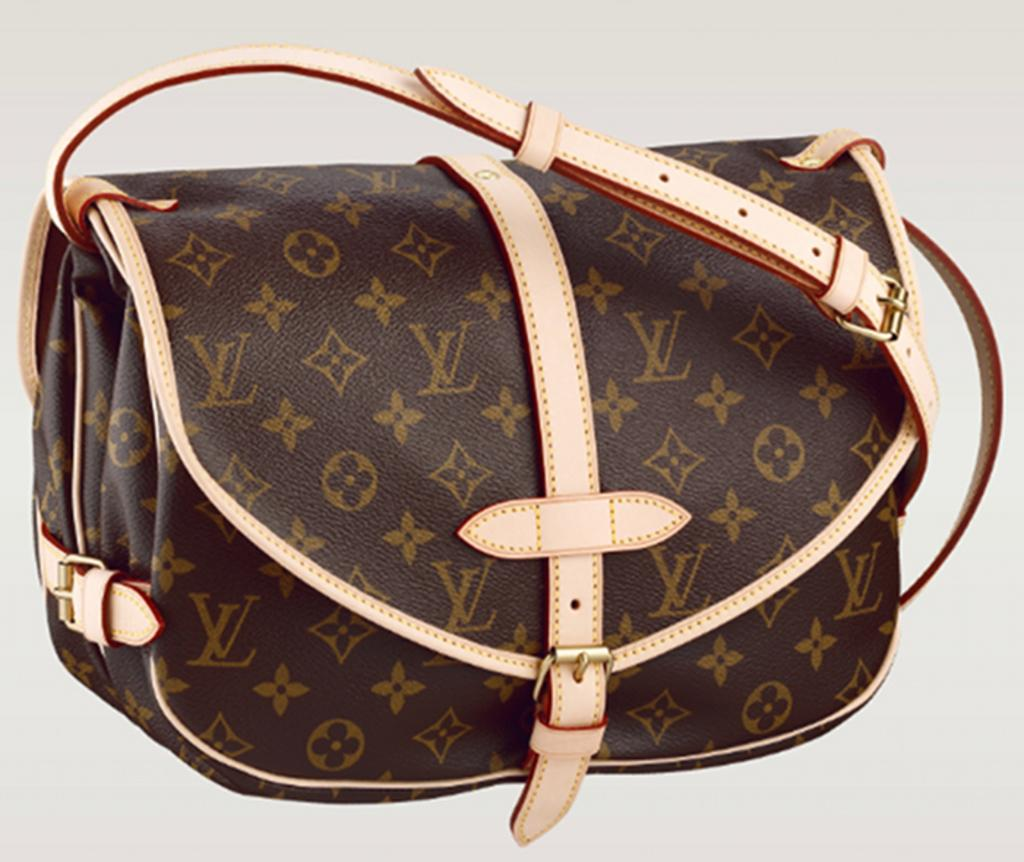What object can be seen in the image? There is a bag in the image. What is the color of the bag? The bag is brown in color. Are there any additional features on the bag? Yes, the bag has a cream-colored belt. Does the bag have a tendency to sit on a throne in the image? There is no throne present in the image, and the bag is not depicted as sitting on anything. 